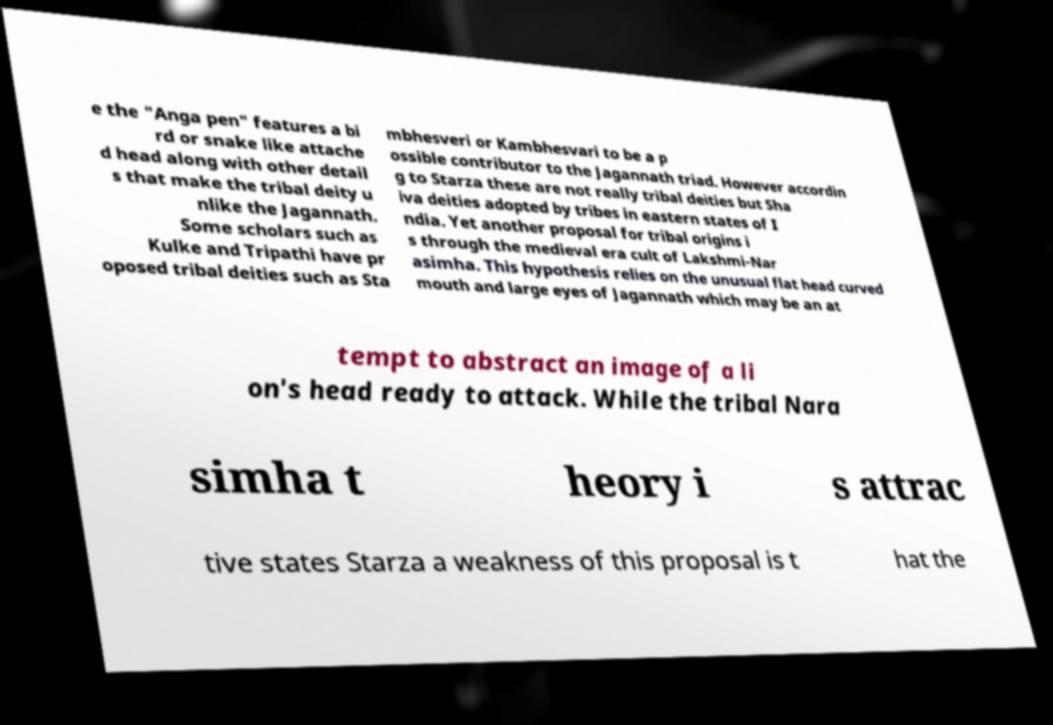Could you extract and type out the text from this image? e the "Anga pen" features a bi rd or snake like attache d head along with other detail s that make the tribal deity u nlike the Jagannath. Some scholars such as Kulke and Tripathi have pr oposed tribal deities such as Sta mbhesveri or Kambhesvari to be a p ossible contributor to the Jagannath triad. However accordin g to Starza these are not really tribal deities but Sha iva deities adopted by tribes in eastern states of I ndia. Yet another proposal for tribal origins i s through the medieval era cult of Lakshmi-Nar asimha. This hypothesis relies on the unusual flat head curved mouth and large eyes of Jagannath which may be an at tempt to abstract an image of a li on's head ready to attack. While the tribal Nara simha t heory i s attrac tive states Starza a weakness of this proposal is t hat the 